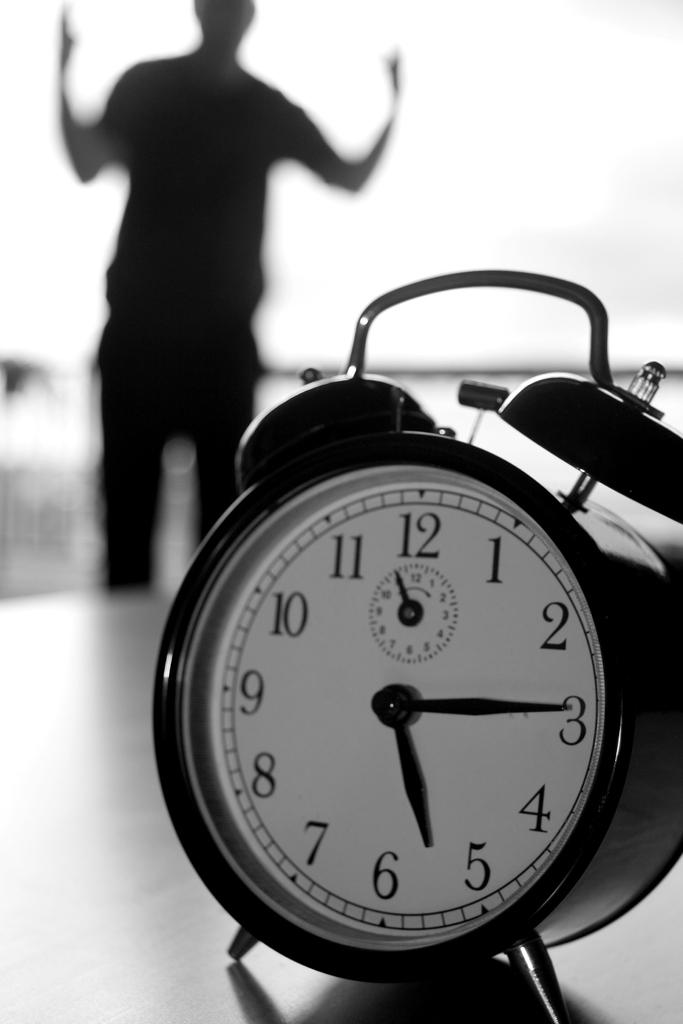<image>
Share a concise interpretation of the image provided. An alarm clock shows the time 5:15 and a man is surprised in the background. 